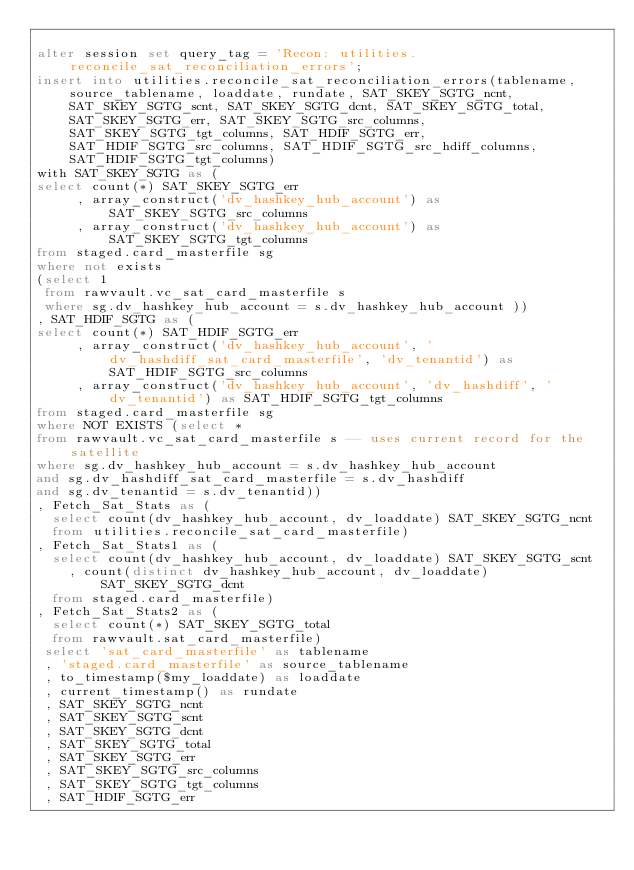<code> <loc_0><loc_0><loc_500><loc_500><_SQL_>
alter session set query_tag = 'Recon: utilities.reconcile_sat_reconciliation_errors';
insert into utilities.reconcile_sat_reconciliation_errors(tablename, source_tablename, loaddate, rundate, SAT_SKEY_SGTG_ncnt, SAT_SKEY_SGTG_scnt, SAT_SKEY_SGTG_dcnt, SAT_SKEY_SGTG_total, SAT_SKEY_SGTG_err, SAT_SKEY_SGTG_src_columns, SAT_SKEY_SGTG_tgt_columns, SAT_HDIF_SGTG_err, SAT_HDIF_SGTG_src_columns, SAT_HDIF_SGTG_src_hdiff_columns, SAT_HDIF_SGTG_tgt_columns)
with SAT_SKEY_SGTG as (
select count(*) SAT_SKEY_SGTG_err
     , array_construct('dv_hashkey_hub_account') as SAT_SKEY_SGTG_src_columns
     , array_construct('dv_hashkey_hub_account') as SAT_SKEY_SGTG_tgt_columns
from staged.card_masterfile sg 
where not exists
(select 1
 from rawvault.vc_sat_card_masterfile s
 where sg.dv_hashkey_hub_account = s.dv_hashkey_hub_account ))
, SAT_HDIF_SGTG as (
select count(*) SAT_HDIF_SGTG_err
     , array_construct('dv_hashkey_hub_account', 'dv_hashdiff_sat_card_masterfile', 'dv_tenantid') as SAT_HDIF_SGTG_src_columns
     , array_construct('dv_hashkey_hub_account', 'dv_hashdiff', 'dv_tenantid') as SAT_HDIF_SGTG_tgt_columns
from staged.card_masterfile sg 
where NOT EXISTS (select *
from rawvault.vc_sat_card_masterfile s -- uses current record for the satellite
where sg.dv_hashkey_hub_account = s.dv_hashkey_hub_account
and sg.dv_hashdiff_sat_card_masterfile = s.dv_hashdiff
and sg.dv_tenantid = s.dv_tenantid))
, Fetch_Sat_Stats as (
  select count(dv_hashkey_hub_account, dv_loaddate) SAT_SKEY_SGTG_ncnt
  from utilities.reconcile_sat_card_masterfile)
, Fetch_Sat_Stats1 as (
  select count(dv_hashkey_hub_account, dv_loaddate) SAT_SKEY_SGTG_scnt
    , count(distinct dv_hashkey_hub_account, dv_loaddate) SAT_SKEY_SGTG_dcnt
  from staged.card_masterfile)
, Fetch_Sat_Stats2 as (
  select count(*) SAT_SKEY_SGTG_total
  from rawvault.sat_card_masterfile)
 select 'sat_card_masterfile' as tablename
 , 'staged.card_masterfile' as source_tablename
 , to_timestamp($my_loaddate) as loaddate
 , current_timestamp() as rundate
 , SAT_SKEY_SGTG_ncnt
 , SAT_SKEY_SGTG_scnt
 , SAT_SKEY_SGTG_dcnt
 , SAT_SKEY_SGTG_total
 , SAT_SKEY_SGTG_err
 , SAT_SKEY_SGTG_src_columns
 , SAT_SKEY_SGTG_tgt_columns
 , SAT_HDIF_SGTG_err</code> 